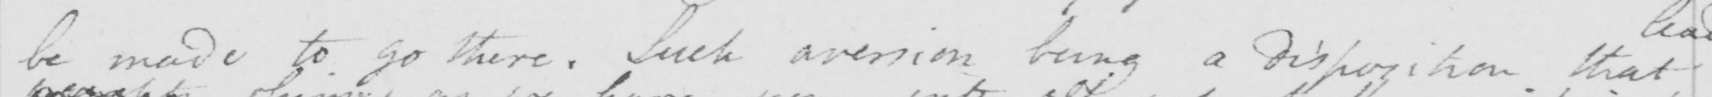Please provide the text content of this handwritten line. be made to go there . Such aversion being a disposition that 